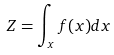Convert formula to latex. <formula><loc_0><loc_0><loc_500><loc_500>Z = \int _ { x } f ( x ) d x</formula> 